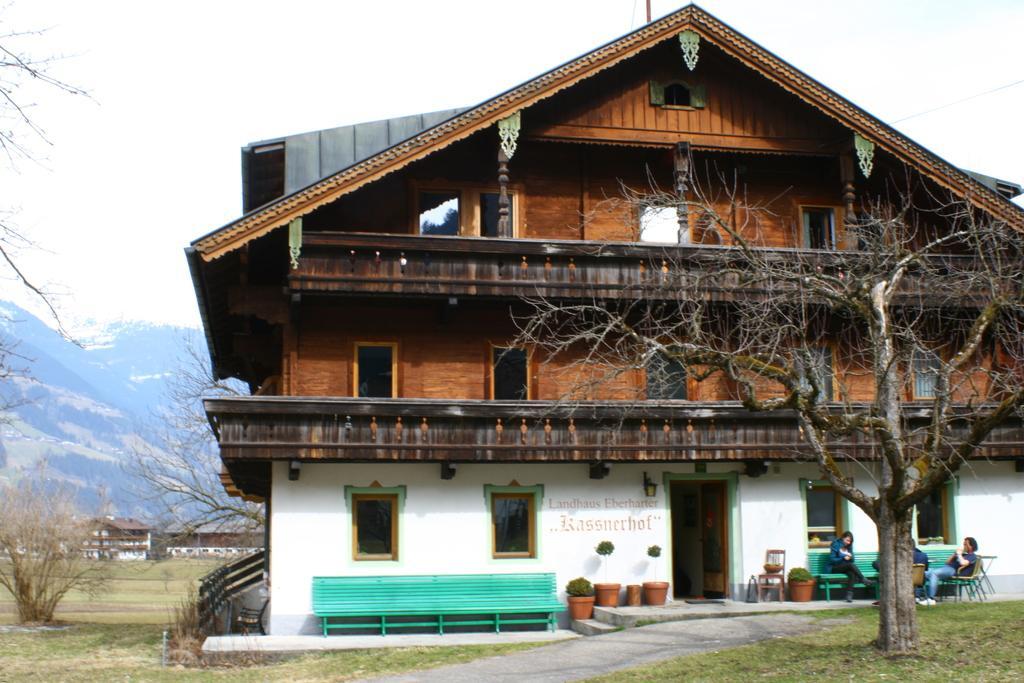Describe this image in one or two sentences. In this image, I can see a tree on the right side and there are some people sitting on the chairs and there are some plants and in the middle I can see a house and on the left side we can see some more houses. 